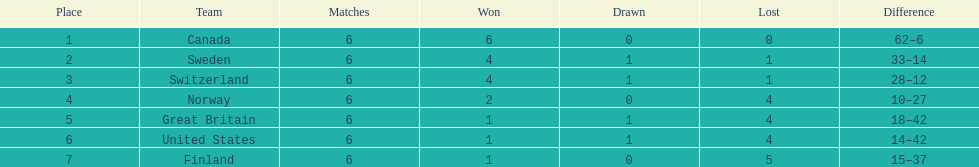During the 1951 world ice hockey championships, what was the difference between the first and last place teams for number of games won ? 5. 